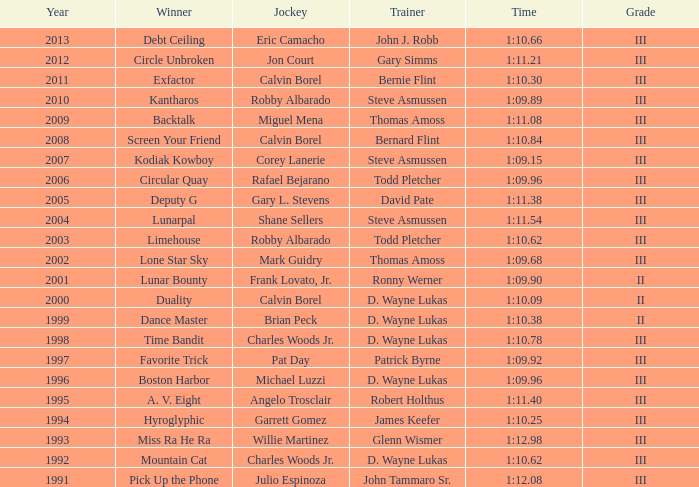In a year prior to 2010, which coach emerged victorious in the hyroglyphic? James Keefer. 